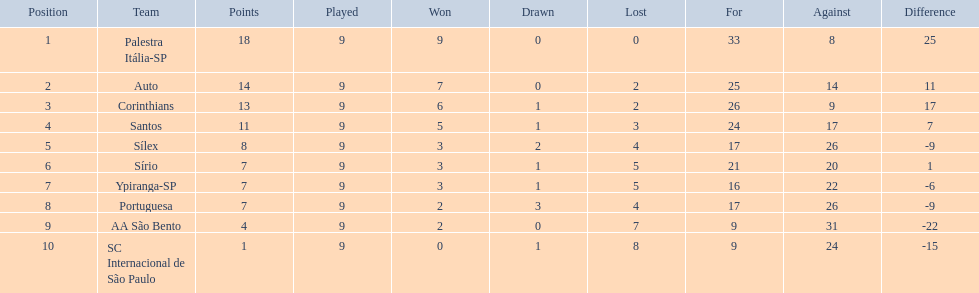How many teams had more points than silex? 4. 